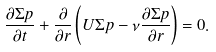Convert formula to latex. <formula><loc_0><loc_0><loc_500><loc_500>\frac { \partial \Sigma p } { \partial t } + \frac { \partial } { \partial r } \left ( U \Sigma p - \nu \frac { \partial \Sigma p } { \partial r } \right ) = 0 .</formula> 